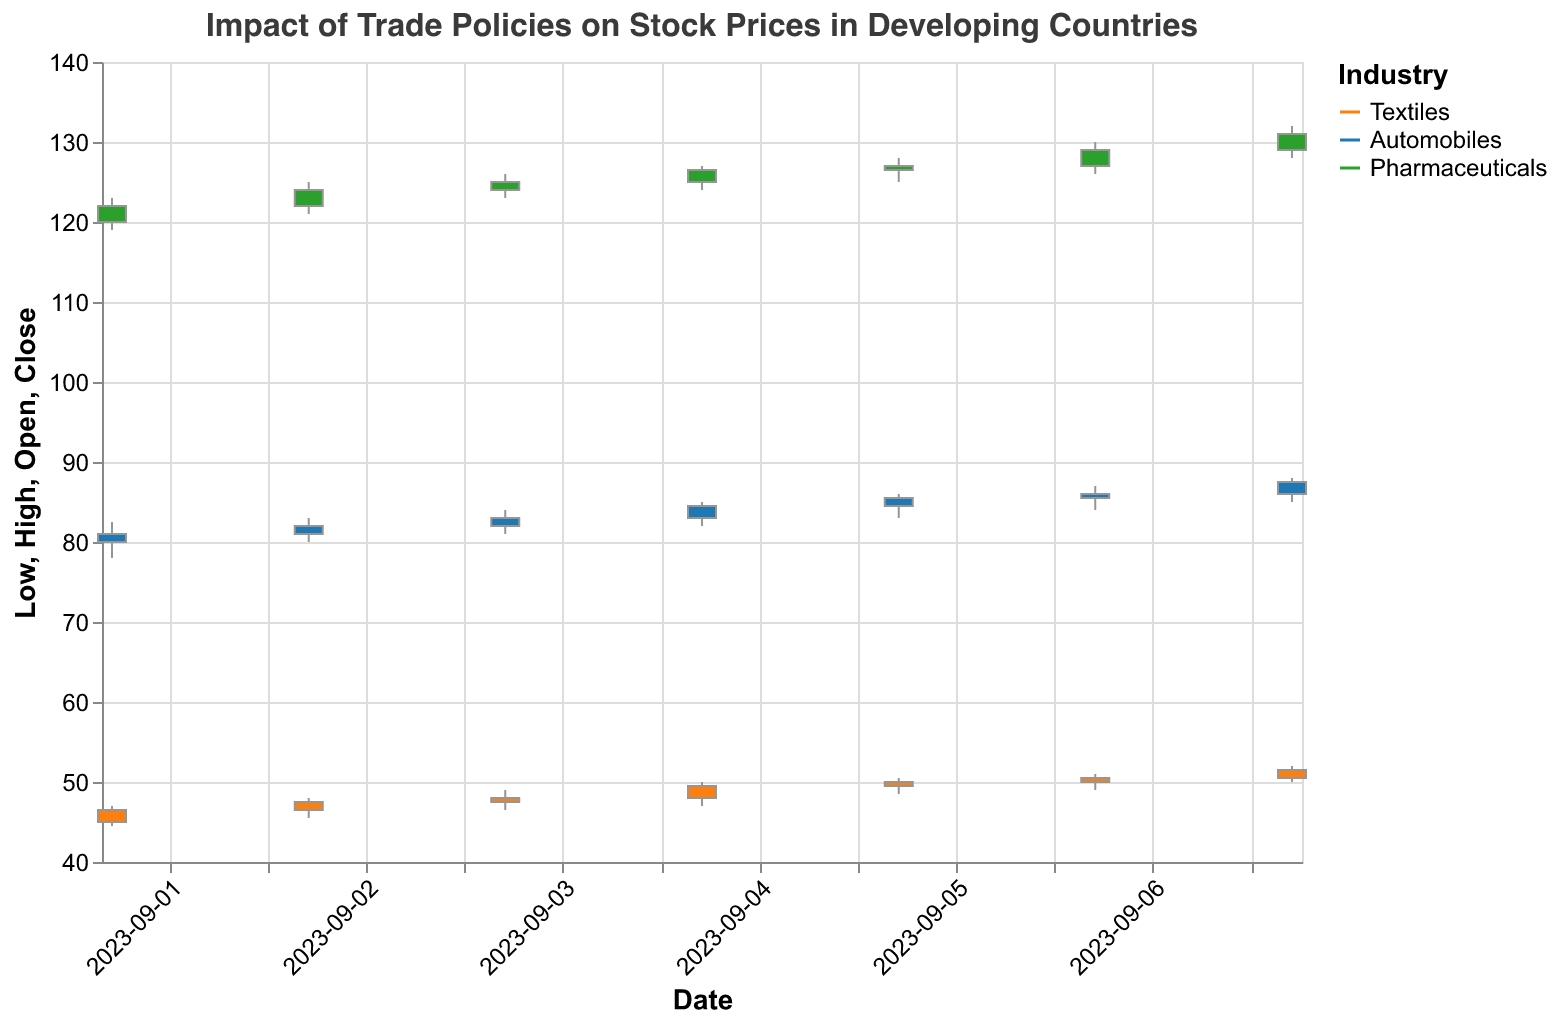Which industry has the highest stock price on 2023-09-01? The "Pharmaceuticals" industry has a closing stock price of 122.00, which is higher than "Textiles" at 46.50 and "Automobiles" at 81.00.
Answer: Pharmaceuticals Did any industry experience a policy change on 2023-09-03? There was no policy change on 2023-09-03 for all listed industries (Textiles, Automobiles, Pharmaceuticals).
Answer: No What is the trend in the stock price for the "Textiles" industry after the policy change on 2023-09-01? On 2023-09-01, the "Textiles" industry stock closes at 46.50. After 2023-09-01: 
- 2023-09-02: 47.50,
- 2023-09-03: 48.00,
- 2023-09-04: 49.50,
- 2023-09-05: 50.00,
showing an increasing trend until 2023-09-05.
On 2023-09-06 and 2023-09-07, the prices further increase to 50.50 and 51.50 respectively, confirming a continued upward trend after the policy change.
Answer: Increasing Which industry had the largest volume of stock traded on 2023-09-07? On 2023-09-07, the "Automobiles" industry had the largest volume of stock traded with 26000. "Textiles" had 21000, and "Pharmaceuticals" had 16000.
Answer: Automobiles Compare the closing stock prices of "Automobiles" on 2023-09-06 and 2023-09-07. Which day had a higher closing price? On 2023-09-06, the closing price for "Automobiles" was 86.00. On 2023-09-07, the closing price was 87.50. Therefore, 2023-09-07 had a higher closing price.
Answer: 2023-09-07 Did the "Pharmaceuticals" industry stock price close higher or lower than its opening price on 2023-09-01? The "Pharmaceuticals" industry opened at 120.00 on 2023-09-01 and closed at 122.00. Since 122.00 is higher than 120.00, it closed higher than its opening price.
Answer: Higher Calculate the average closing price of the "Textiles" industry from 2023-09-01 to 2023-09-07. The closing prices for "Textiles" from 2023-09-01 to 2023-09-07 are: 
- 2023-09-01: 46.50
- 2023-09-02: 47.50
- 2023-09-03: 48.00
- 2023-09-04: 49.50
- 2023-09-05: 50.00
- 2023-09-06: 50.50
- 2023-09-07: 51.50
The average = (46.50 + 47.50 + 48.00 + 49.50 + 50.00 + 50.50 + 51.50) / 7 = 343.50 / 7 = 49.07.
Answer: 49.07 What impact did policy change on 2023-09-06 have on stock volumes traded in the "Automobiles" industry? On 2023-09-05 (before the policy change), the volume traded was 24000. On 2023-09-06 (policy change day), the volume was 25000, and on 2023-09-07, the volume was 26000. The policy change appears to correlate with an increase in trading volume.
Answer: Volume increased Which day observed the highest overall trading volume among all industries, considering all dates from 2023-09-01 to 2023-09-07? To find the highest overall trading volume among all industries, we need to sum the volume for each day and compare: 
- 2023-09-01: 15000 + 20000 + 10000 = 45000
- 2023-09-02: 16000 + 21000 + 11000 = 48000
- 2023-09-03: 17000 + 22000 + 12000 = 51000
- 2023-09-04: 18000 + 23000 + 13000 = 54000
- 2023-09-05: 19000 + 24000 + 14000 = 57000
- 2023-09-06: 20000 + 25000 + 15000 = 60000
- 2023-09-07: 21000 + 26000 + 16000 = 63000
The highest overall trading volume is on 2023-09-07 with 63000.
Answer: 2023-09-07 